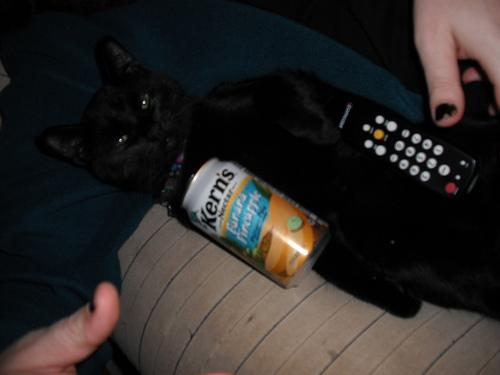The remote control placed on top of the black cat controls what object? Please explain your reasoning. cable box. It has channel and volume buttons 